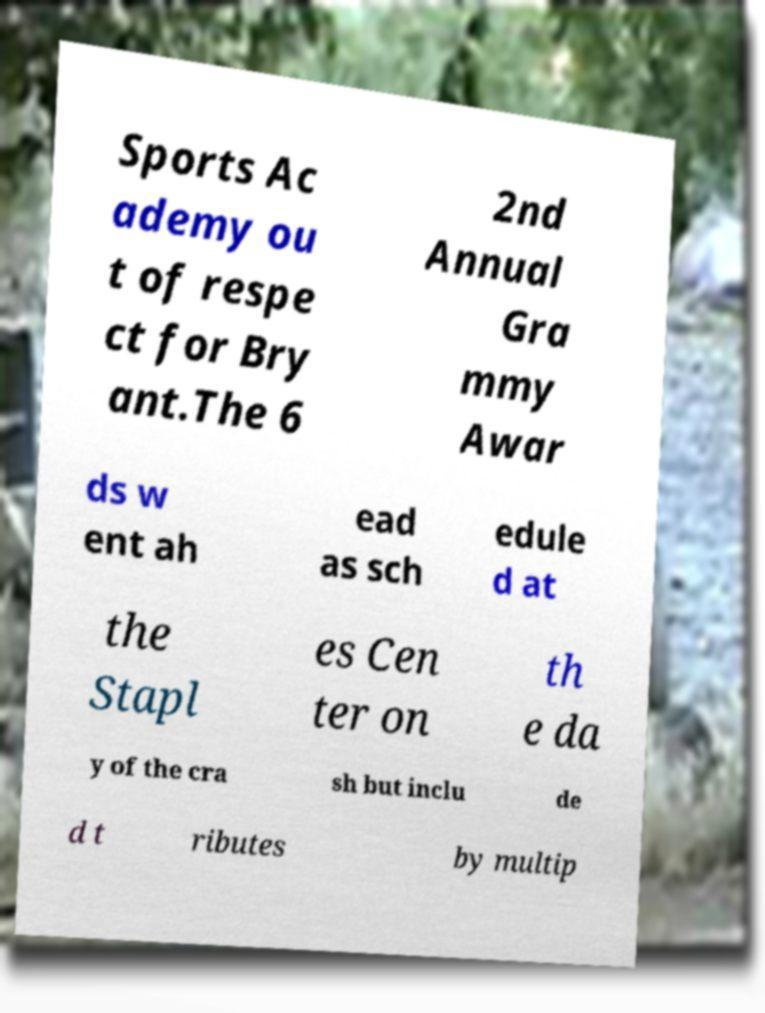Please read and relay the text visible in this image. What does it say? Sports Ac ademy ou t of respe ct for Bry ant.The 6 2nd Annual Gra mmy Awar ds w ent ah ead as sch edule d at the Stapl es Cen ter on th e da y of the cra sh but inclu de d t ributes by multip 